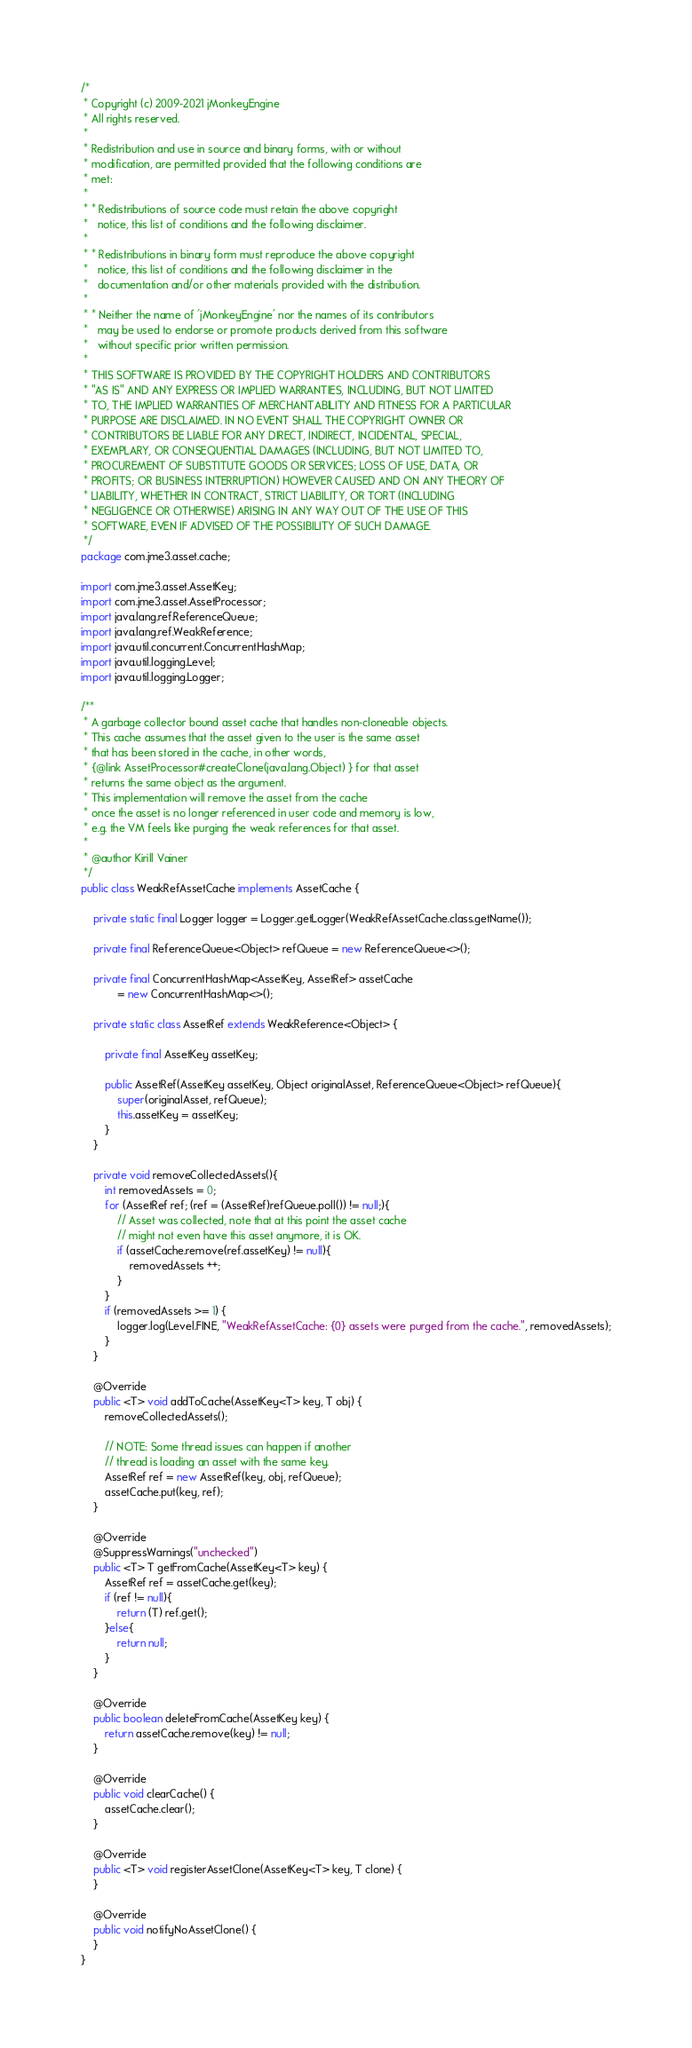Convert code to text. <code><loc_0><loc_0><loc_500><loc_500><_Java_>/*
 * Copyright (c) 2009-2021 jMonkeyEngine
 * All rights reserved.
 *
 * Redistribution and use in source and binary forms, with or without
 * modification, are permitted provided that the following conditions are
 * met:
 *
 * * Redistributions of source code must retain the above copyright
 *   notice, this list of conditions and the following disclaimer.
 *
 * * Redistributions in binary form must reproduce the above copyright
 *   notice, this list of conditions and the following disclaimer in the
 *   documentation and/or other materials provided with the distribution.
 *
 * * Neither the name of 'jMonkeyEngine' nor the names of its contributors
 *   may be used to endorse or promote products derived from this software
 *   without specific prior written permission.
 *
 * THIS SOFTWARE IS PROVIDED BY THE COPYRIGHT HOLDERS AND CONTRIBUTORS
 * "AS IS" AND ANY EXPRESS OR IMPLIED WARRANTIES, INCLUDING, BUT NOT LIMITED
 * TO, THE IMPLIED WARRANTIES OF MERCHANTABILITY AND FITNESS FOR A PARTICULAR
 * PURPOSE ARE DISCLAIMED. IN NO EVENT SHALL THE COPYRIGHT OWNER OR
 * CONTRIBUTORS BE LIABLE FOR ANY DIRECT, INDIRECT, INCIDENTAL, SPECIAL,
 * EXEMPLARY, OR CONSEQUENTIAL DAMAGES (INCLUDING, BUT NOT LIMITED TO,
 * PROCUREMENT OF SUBSTITUTE GOODS OR SERVICES; LOSS OF USE, DATA, OR
 * PROFITS; OR BUSINESS INTERRUPTION) HOWEVER CAUSED AND ON ANY THEORY OF
 * LIABILITY, WHETHER IN CONTRACT, STRICT LIABILITY, OR TORT (INCLUDING
 * NEGLIGENCE OR OTHERWISE) ARISING IN ANY WAY OUT OF THE USE OF THIS
 * SOFTWARE, EVEN IF ADVISED OF THE POSSIBILITY OF SUCH DAMAGE.
 */
package com.jme3.asset.cache;

import com.jme3.asset.AssetKey;
import com.jme3.asset.AssetProcessor;
import java.lang.ref.ReferenceQueue;
import java.lang.ref.WeakReference;
import java.util.concurrent.ConcurrentHashMap;
import java.util.logging.Level;
import java.util.logging.Logger;

/**
 * A garbage collector bound asset cache that handles non-cloneable objects.
 * This cache assumes that the asset given to the user is the same asset
 * that has been stored in the cache, in other words, 
 * {@link AssetProcessor#createClone(java.lang.Object) } for that asset
 * returns the same object as the argument.
 * This implementation will remove the asset from the cache 
 * once the asset is no longer referenced in user code and memory is low,
 * e.g. the VM feels like purging the weak references for that asset.
 * 
 * @author Kirill Vainer
 */
public class WeakRefAssetCache implements AssetCache {

    private static final Logger logger = Logger.getLogger(WeakRefAssetCache.class.getName());
    
    private final ReferenceQueue<Object> refQueue = new ReferenceQueue<>();
    
    private final ConcurrentHashMap<AssetKey, AssetRef> assetCache 
            = new ConcurrentHashMap<>();

    private static class AssetRef extends WeakReference<Object> {
        
        private final AssetKey assetKey;
        
        public AssetRef(AssetKey assetKey, Object originalAsset, ReferenceQueue<Object> refQueue){
            super(originalAsset, refQueue);
            this.assetKey = assetKey;
        }
    }
    
    private void removeCollectedAssets(){
        int removedAssets = 0;
        for (AssetRef ref; (ref = (AssetRef)refQueue.poll()) != null;){
            // Asset was collected, note that at this point the asset cache 
            // might not even have this asset anymore, it is OK.
            if (assetCache.remove(ref.assetKey) != null){
                removedAssets ++;
            }
        }
        if (removedAssets >= 1) {
            logger.log(Level.FINE, "WeakRefAssetCache: {0} assets were purged from the cache.", removedAssets);
        }
    }
    
    @Override
    public <T> void addToCache(AssetKey<T> key, T obj) {
        removeCollectedAssets();
        
        // NOTE: Some thread issues can happen if another
        // thread is loading an asset with the same key.
        AssetRef ref = new AssetRef(key, obj, refQueue);
        assetCache.put(key, ref);
    }

    @Override
    @SuppressWarnings("unchecked")
    public <T> T getFromCache(AssetKey<T> key) {
        AssetRef ref = assetCache.get(key);
        if (ref != null){
            return (T) ref.get();
        }else{
            return null;
        }
    }

    @Override
    public boolean deleteFromCache(AssetKey key) {
        return assetCache.remove(key) != null;
    }

    @Override
    public void clearCache() {
        assetCache.clear();
    }
    
    @Override
    public <T> void registerAssetClone(AssetKey<T> key, T clone) {
    }
    
    @Override
    public void notifyNoAssetClone() {
    }
}
</code> 